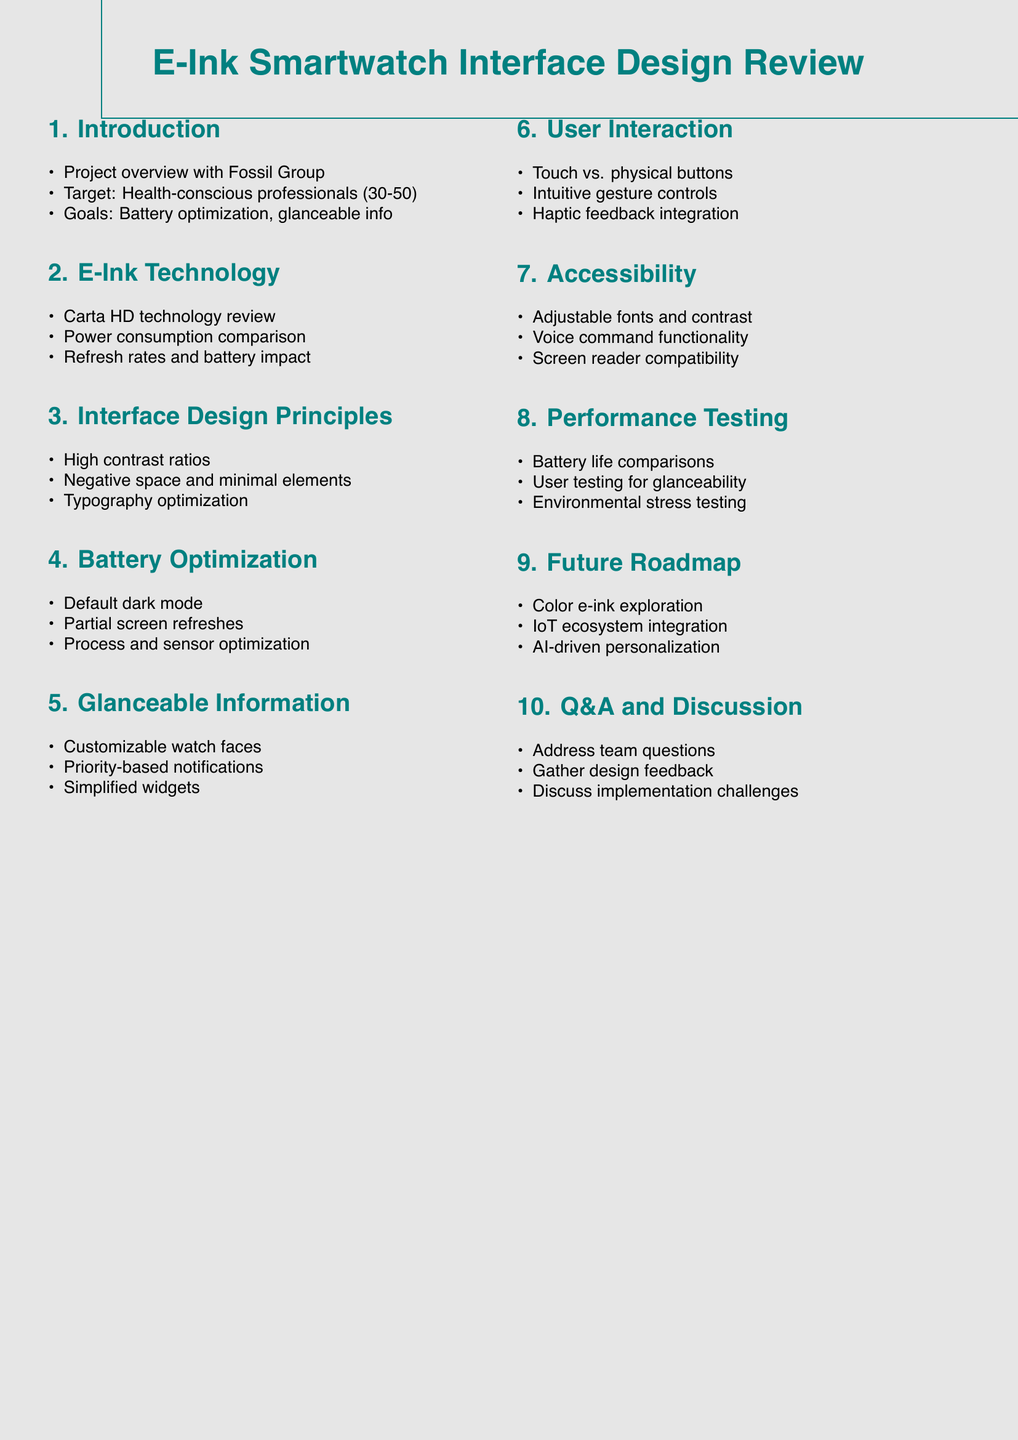What is the target audience for the smartwatch? The document specifies the target audience as health-conscious professionals aged 30-50.
Answer: Health-conscious professionals aged 30-50 What is the key design goal mentioned in the agenda? The agenda highlights the key design goals as battery life optimization and glanceable information display.
Answer: Battery life optimization and glanceable information display What technology is used in the e-ink display? The document references E Ink's latest Carta HD technology.
Answer: Carta HD technology What is one battery life optimization strategy mentioned? The agenda item on battery life optimization discusses implementing dark mode as the default interface.
Answer: Dark mode as default interface How is glanceable information displayed on the smartwatch? The document describes the design of customizable watch faces with key information as part of glanceable information display.
Answer: Customizable watch faces What interaction method is evaluated in the user interaction section? The user interaction section mentions evaluating touch versus physical button interactions.
Answer: Touch vs. physical buttons What feature is included for accessibility? The document states that adjustable font sizes and high-contrast modes are included for accessibility considerations.
Answer: Adjustable font sizes and high-contrast modes What will be explored for future enhancements? The agenda indicates that exploration of color e-ink technology will be part of future enhancements.
Answer: Color e-ink technology What aspect is covered in the performance testing section? The performance testing section includes battery life comparisons with competing smartwatches.
Answer: Battery life comparisons 